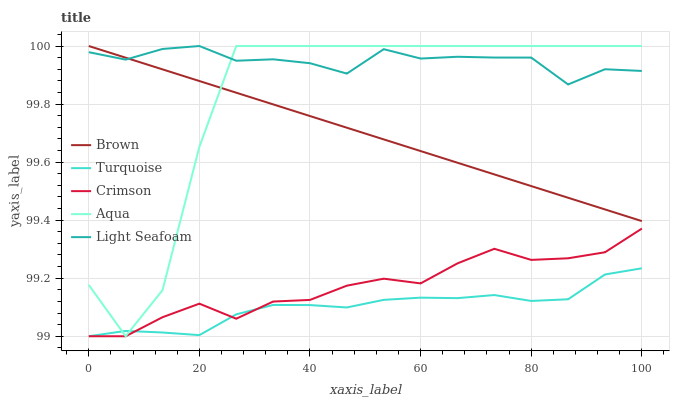Does Turquoise have the minimum area under the curve?
Answer yes or no. Yes. Does Light Seafoam have the maximum area under the curve?
Answer yes or no. Yes. Does Brown have the minimum area under the curve?
Answer yes or no. No. Does Brown have the maximum area under the curve?
Answer yes or no. No. Is Brown the smoothest?
Answer yes or no. Yes. Is Aqua the roughest?
Answer yes or no. Yes. Is Turquoise the smoothest?
Answer yes or no. No. Is Turquoise the roughest?
Answer yes or no. No. Does Crimson have the lowest value?
Answer yes or no. Yes. Does Brown have the lowest value?
Answer yes or no. No. Does Aqua have the highest value?
Answer yes or no. Yes. Does Turquoise have the highest value?
Answer yes or no. No. Is Turquoise less than Light Seafoam?
Answer yes or no. Yes. Is Light Seafoam greater than Crimson?
Answer yes or no. Yes. Does Aqua intersect Light Seafoam?
Answer yes or no. Yes. Is Aqua less than Light Seafoam?
Answer yes or no. No. Is Aqua greater than Light Seafoam?
Answer yes or no. No. Does Turquoise intersect Light Seafoam?
Answer yes or no. No. 